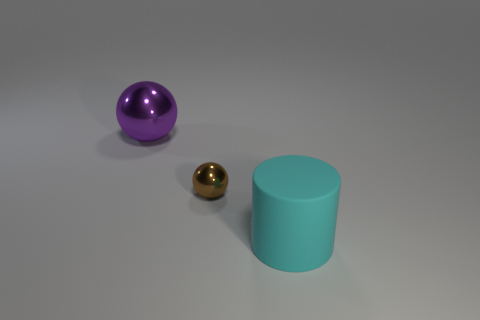Subtract 1 cylinders. How many cylinders are left? 0 Add 1 small metal balls. How many objects exist? 4 Subtract all purple blocks. How many gray cylinders are left? 0 Add 3 big purple metallic cylinders. How many big purple metallic cylinders exist? 3 Subtract 0 blue spheres. How many objects are left? 3 Subtract all spheres. How many objects are left? 1 Subtract all red balls. Subtract all yellow cylinders. How many balls are left? 2 Subtract all cylinders. Subtract all cyan rubber cylinders. How many objects are left? 1 Add 3 rubber things. How many rubber things are left? 4 